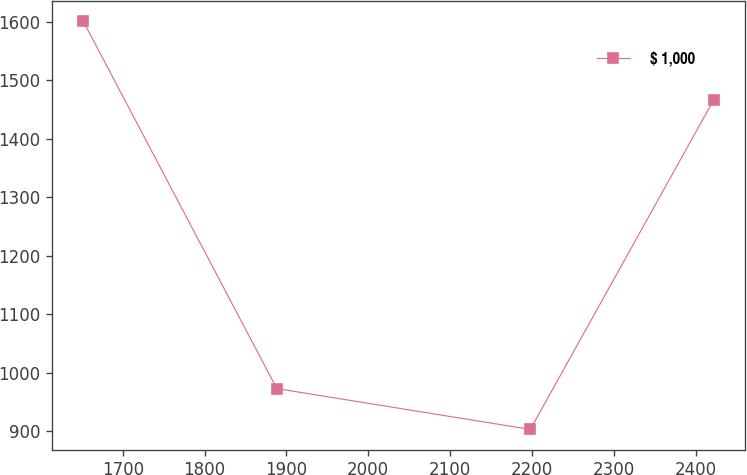Convert chart to OTSL. <chart><loc_0><loc_0><loc_500><loc_500><line_chart><ecel><fcel>$ 1,000<nl><fcel>1651.76<fcel>1600.99<nl><fcel>1888.24<fcel>972.71<nl><fcel>2197.89<fcel>902.9<nl><fcel>2421.89<fcel>1466.15<nl></chart> 